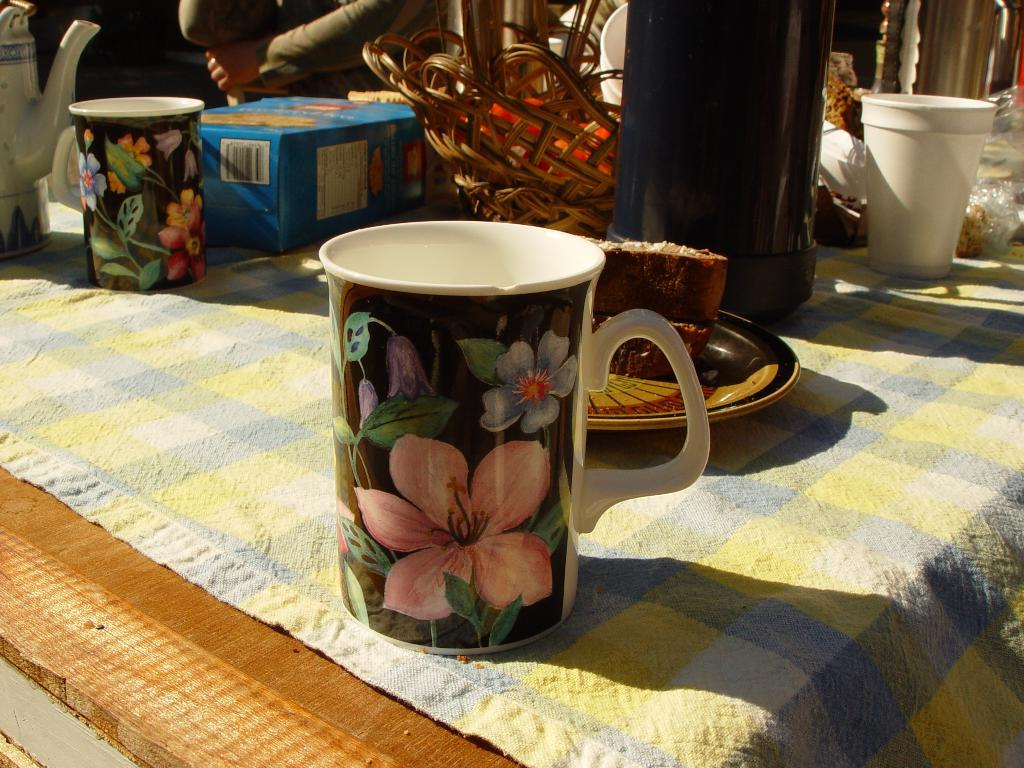What type of objects are on the table in the image? There are cups, a bottle, and a kettle on the table in the image. Can you describe the bottle on the table? The bottle on the table is likely a container for a beverage. What might the kettle be used for? The kettle on the table might be used for boiling water or making tea. What letters are written on the cups in the image? There is no information about letters or any writing on the cups in the image. 